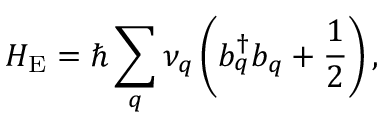<formula> <loc_0><loc_0><loc_500><loc_500>H _ { E } = \hbar { \sum } _ { q } \nu _ { q } \left ( b _ { q } ^ { \dagger } b _ { q } + \frac { 1 } { 2 } \right ) ,</formula> 